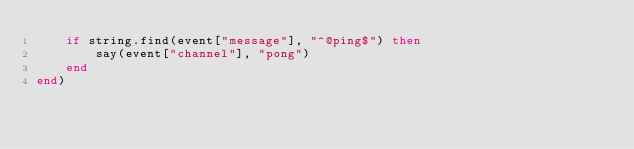<code> <loc_0><loc_0><loc_500><loc_500><_Lua_>    if string.find(event["message"], "^@ping$") then
        say(event["channel"], "pong")
    end
end)
</code> 